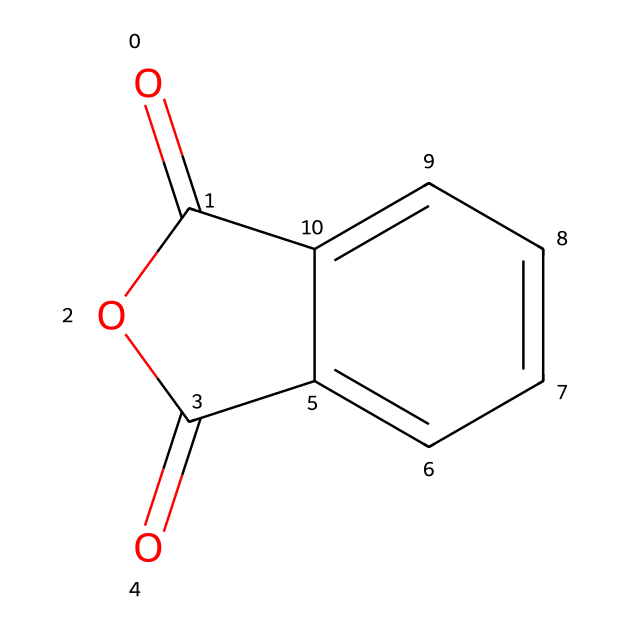What is the molecular formula of phthalic anhydride? The SMILES representation contains a carbonyl group and two carbonyls from the anhydride function. Counting the atoms yields C8H4O3.
Answer: C8H4O3 How many carbon atoms are present in phthalic anhydride? By analyzing the SMILES structure, we count a total of 8 carbon atoms within the ring and functional groups.
Answer: 8 What type of functional groups are present in phthalic anhydride? The structure shows two carbonyl (C=O) groups and an anhydride formed by the loss of water. Thus, it features acyclic anhydride functionality.
Answer: anhydride, carbonyl What kind of reaction can phthalic anhydride undergo? Phthalic anhydride can hydrolyze in the presence of water to form phthalic acid, demonstrating a typical reaction behavior for acid anhydrides.
Answer: hydrolysis What is the significance of the ring structure in phthalic anhydride? The cyclic structure contributes to the stability of the molecule and can affect its reactivity, particularly in ongoing reactions or in interactions with other cosmetic ingredients.
Answer: stability, reactivity How many oxygen atoms are in the phthalic anhydride molecule? Examination of the SMILES reveals a total of 3 oxygen atoms present in the structure, which corresponds to the two carbonyls and the anhydride linkage.
Answer: 3 What type of chemical is phthalic anhydride classified as? Phthalic anhydride is specifically classified as an acid anhydride due to its structure and behavior with acids.
Answer: acid anhydride 